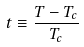<formula> <loc_0><loc_0><loc_500><loc_500>t \equiv \frac { T - T _ { c } } { T _ { c } }</formula> 